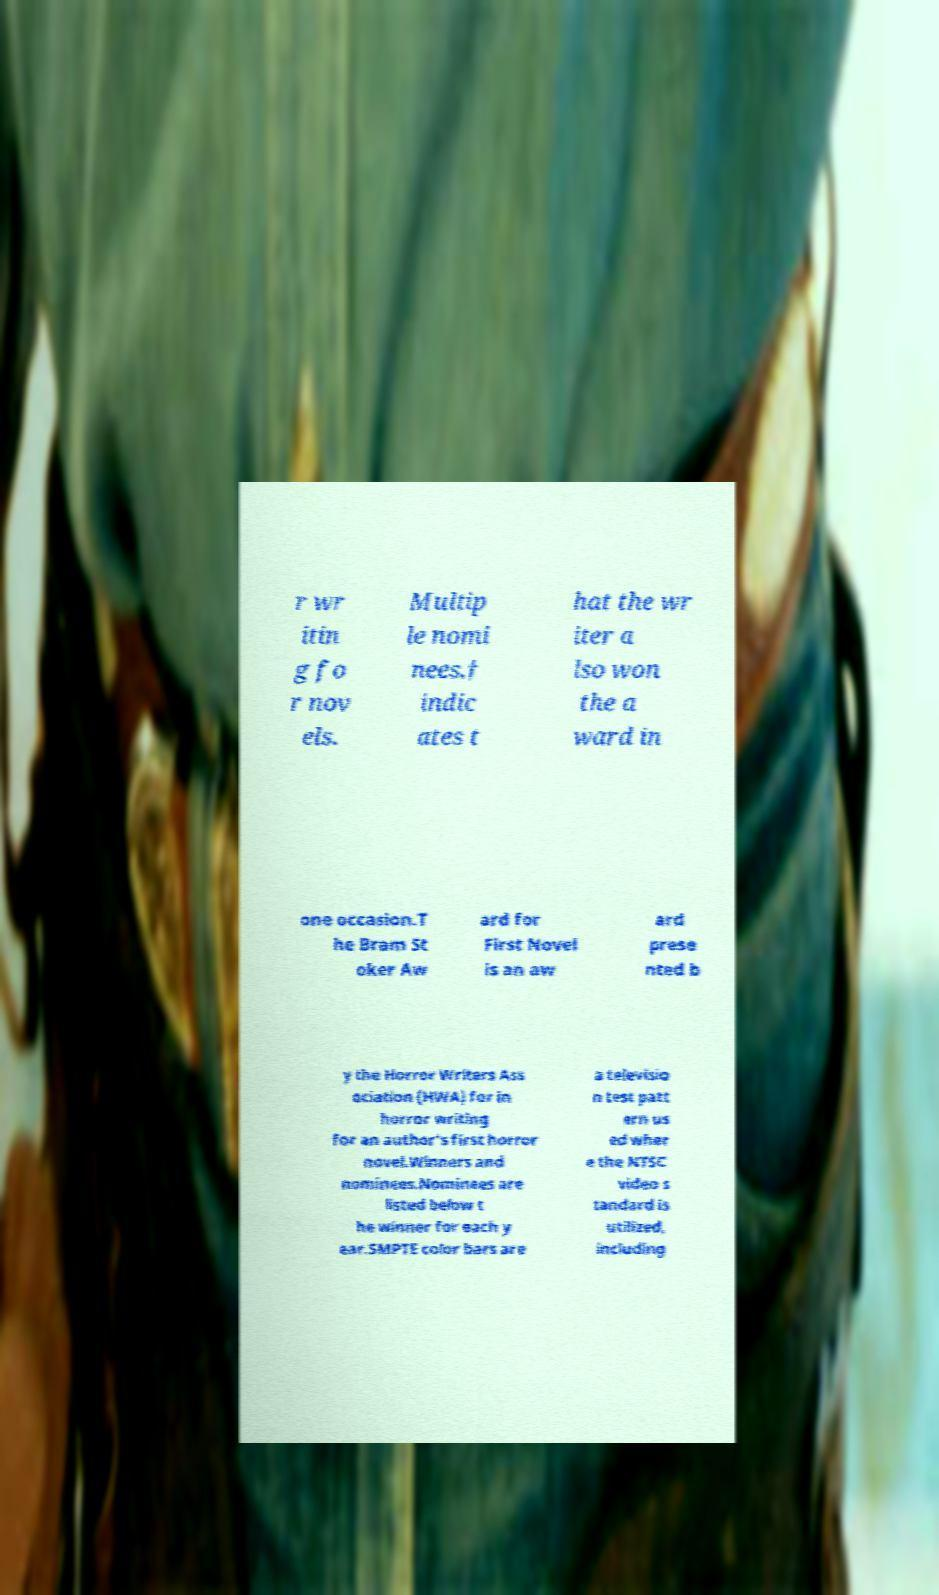Could you assist in decoding the text presented in this image and type it out clearly? r wr itin g fo r nov els. Multip le nomi nees.† indic ates t hat the wr iter a lso won the a ward in one occasion.T he Bram St oker Aw ard for First Novel is an aw ard prese nted b y the Horror Writers Ass ociation (HWA) for in horror writing for an author's first horror novel.Winners and nominees.Nominees are listed below t he winner for each y ear.SMPTE color bars are a televisio n test patt ern us ed wher e the NTSC video s tandard is utilized, including 